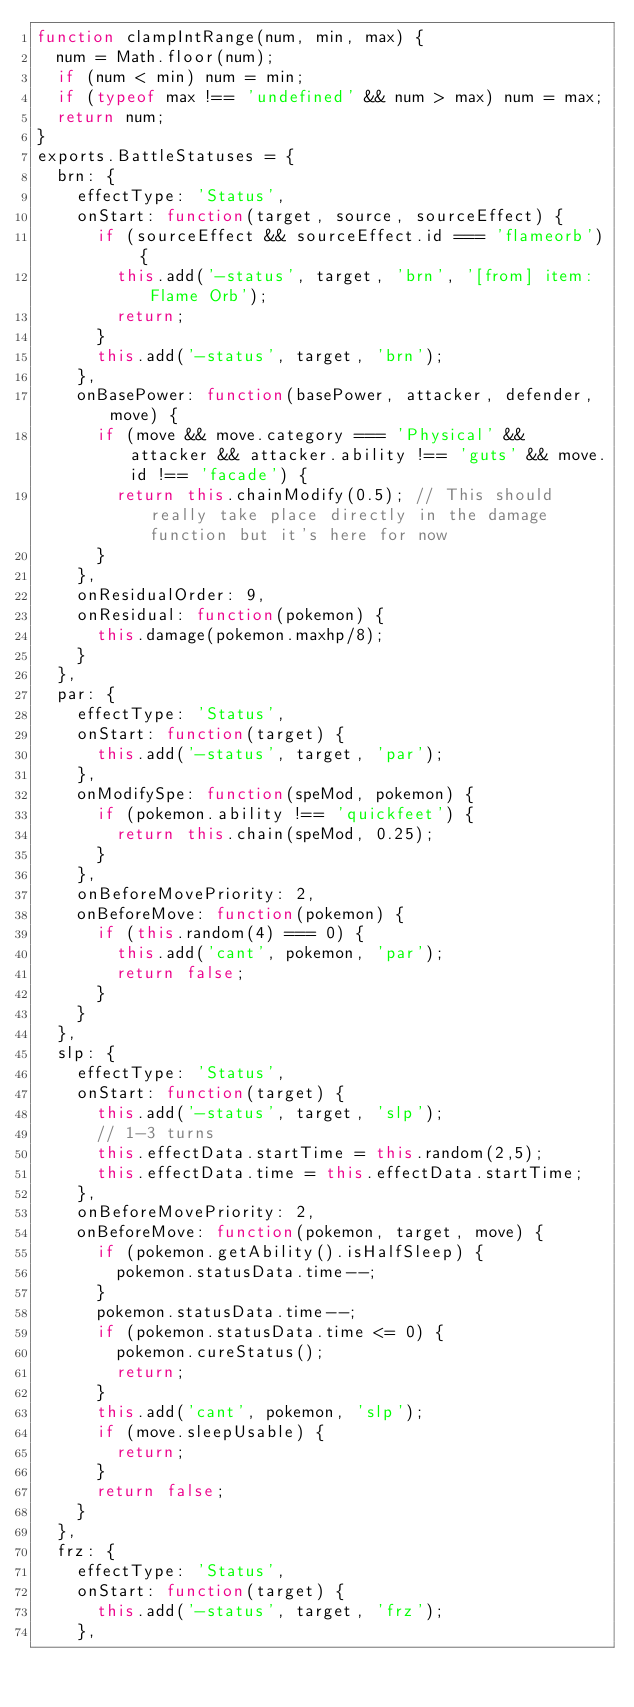<code> <loc_0><loc_0><loc_500><loc_500><_JavaScript_>function clampIntRange(num, min, max) {
	num = Math.floor(num);
	if (num < min) num = min;
	if (typeof max !== 'undefined' && num > max) num = max;
	return num;
}
exports.BattleStatuses = {
	brn: {
		effectType: 'Status',
		onStart: function(target, source, sourceEffect) {
			if (sourceEffect && sourceEffect.id === 'flameorb') {
				this.add('-status', target, 'brn', '[from] item: Flame Orb');
				return;
			}
			this.add('-status', target, 'brn');
		},
		onBasePower: function(basePower, attacker, defender, move) {
			if (move && move.category === 'Physical' && attacker && attacker.ability !== 'guts' && move.id !== 'facade') {
				return this.chainModify(0.5); // This should really take place directly in the damage function but it's here for now
			}
		},
		onResidualOrder: 9,
		onResidual: function(pokemon) {
			this.damage(pokemon.maxhp/8);
		}
	},
	par: {
		effectType: 'Status',
		onStart: function(target) {
			this.add('-status', target, 'par');
		},
		onModifySpe: function(speMod, pokemon) {
			if (pokemon.ability !== 'quickfeet') {
				return this.chain(speMod, 0.25);
			}
		},
		onBeforeMovePriority: 2,
		onBeforeMove: function(pokemon) {
			if (this.random(4) === 0) {
				this.add('cant', pokemon, 'par');
				return false;
			}
		}
	},
	slp: {
		effectType: 'Status',
		onStart: function(target) {
			this.add('-status', target, 'slp');
			// 1-3 turns
			this.effectData.startTime = this.random(2,5);
			this.effectData.time = this.effectData.startTime;
		},
		onBeforeMovePriority: 2,
		onBeforeMove: function(pokemon, target, move) {
			if (pokemon.getAbility().isHalfSleep) {
				pokemon.statusData.time--;
			}
			pokemon.statusData.time--;
			if (pokemon.statusData.time <= 0) {
				pokemon.cureStatus();
				return;
			}
			this.add('cant', pokemon, 'slp');
			if (move.sleepUsable) {
				return;
			}
			return false;
		}
	},
	frz: {
		effectType: 'Status',
		onStart: function(target) {
			this.add('-status', target, 'frz');
		},</code> 